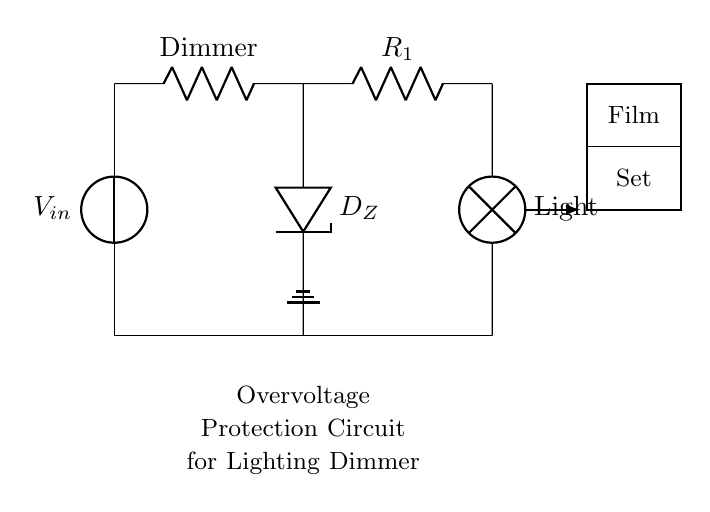What component is used for overvoltage protection? The circuit includes a Zener diode labeled D_Z, which is specifically designed for overvoltage protection by allowing current to pass back to the source when the voltage exceeds a specified level.
Answer: Zener diode What is the function of the resistor labeled R1? The resistor R1 is placed in series with the Zener diode to limit the current flowing through the diode, ensuring it operates within safe limits and preventing damage to the circuit components.
Answer: Current limiting What is the load connected to the circuit? The load in the circuit is represented by a lamp labeled as Light, which consumes electrical energy provided by the dimmer control.
Answer: Lamp How many components are in total connected between the power source and the load? There are four components in total: the power source, the dimmer, the Zener diode, and the resistor before the load (lamp), connecting them directly in sequence.
Answer: Four components What type of control is used for adjusting the light intensity? The dimmer control is used, which allows the operator to vary the voltage applied to the lamp, thus controlling its brightness effectively.
Answer: Dimmer control What is the main purpose of the overvoltage protection circuit? The primary purpose is to safeguard the lighting dimmer and the load from excessive voltage that could cause damage, ensuring a stable operation on film sets.
Answer: Safeguarding What device is used to represent the electrical connection to the ground? The circuit diagram features a ground symbol, indicating the electrical connection to the ground for safety and stability in the circuit.
Answer: Ground symbol 